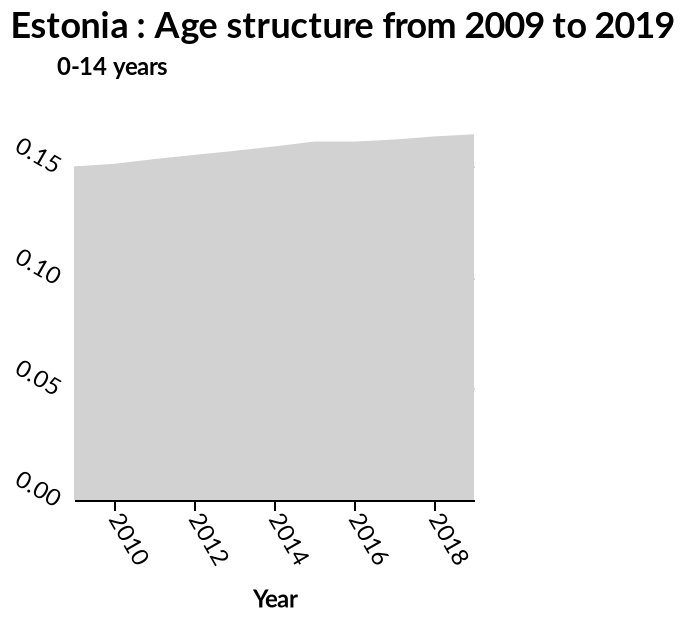<image>
Can the age structure be described as continuously increasing? No, the age structure increased linearly from 2010 to 2015, then levelled off before increasing again from 2016. 